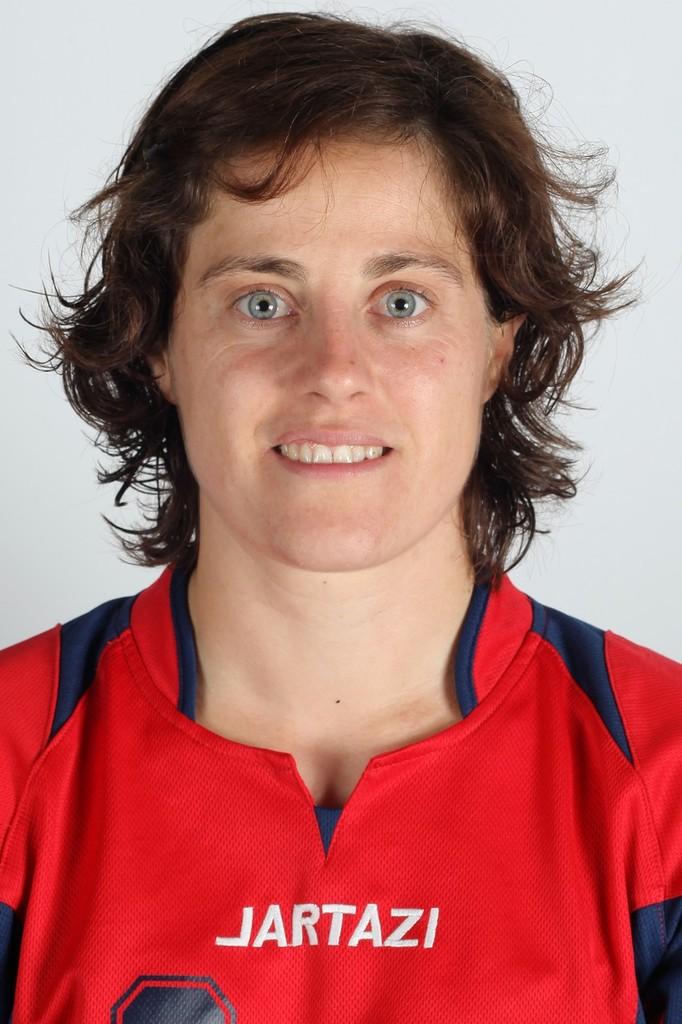What is written on this person's shirt?
Provide a succinct answer. Jartazi. 